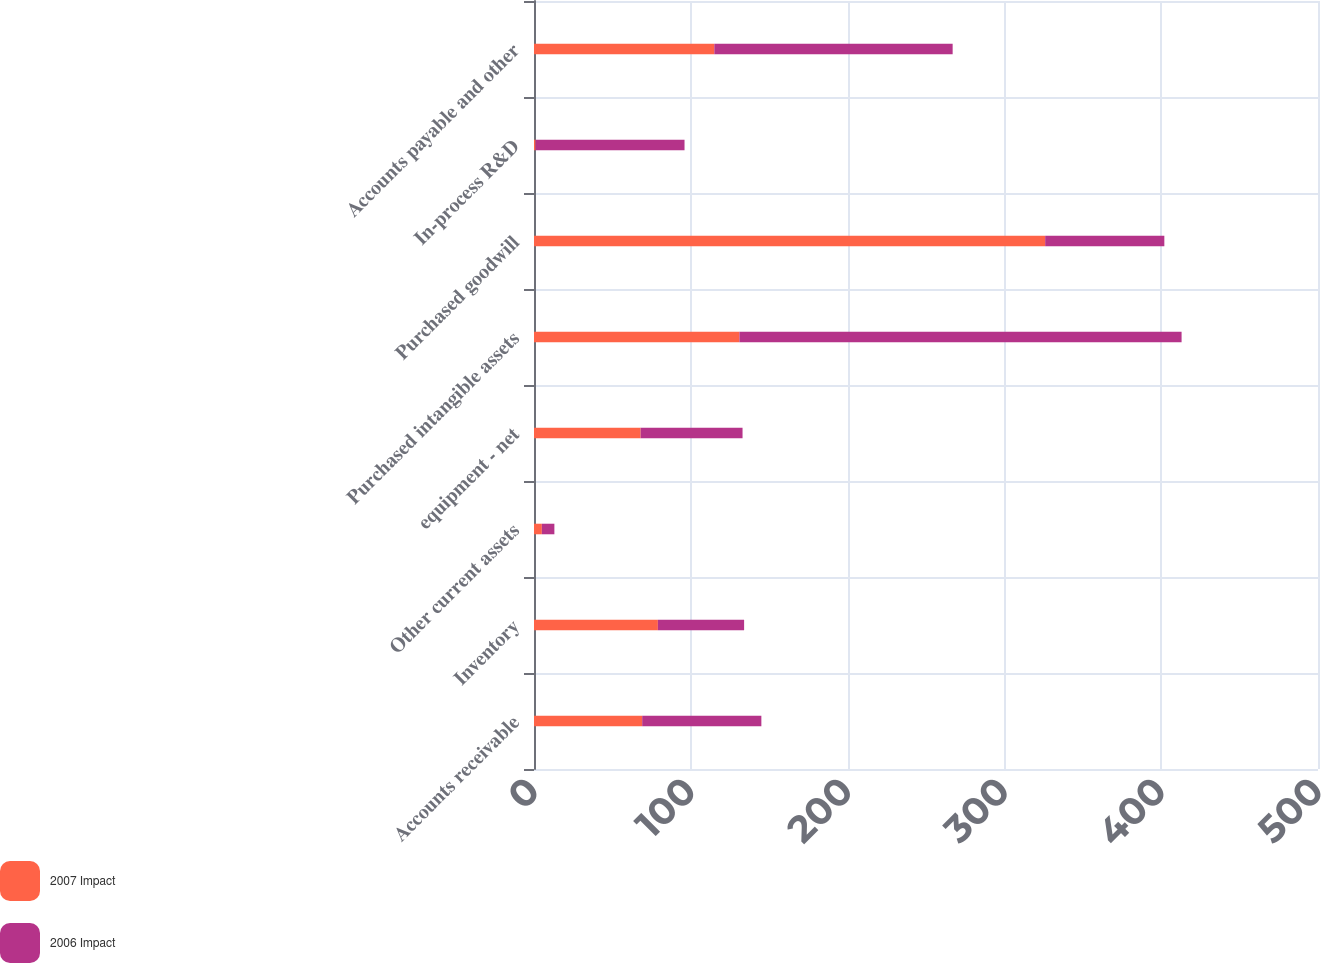Convert chart to OTSL. <chart><loc_0><loc_0><loc_500><loc_500><stacked_bar_chart><ecel><fcel>Accounts receivable<fcel>Inventory<fcel>Other current assets<fcel>equipment - net<fcel>Purchased intangible assets<fcel>Purchased goodwill<fcel>In-process R&D<fcel>Accounts payable and other<nl><fcel>2007 Impact<fcel>69<fcel>79<fcel>5<fcel>68<fcel>131<fcel>326<fcel>1<fcel>115<nl><fcel>2006 Impact<fcel>76<fcel>55<fcel>8<fcel>65<fcel>282<fcel>76<fcel>95<fcel>152<nl></chart> 